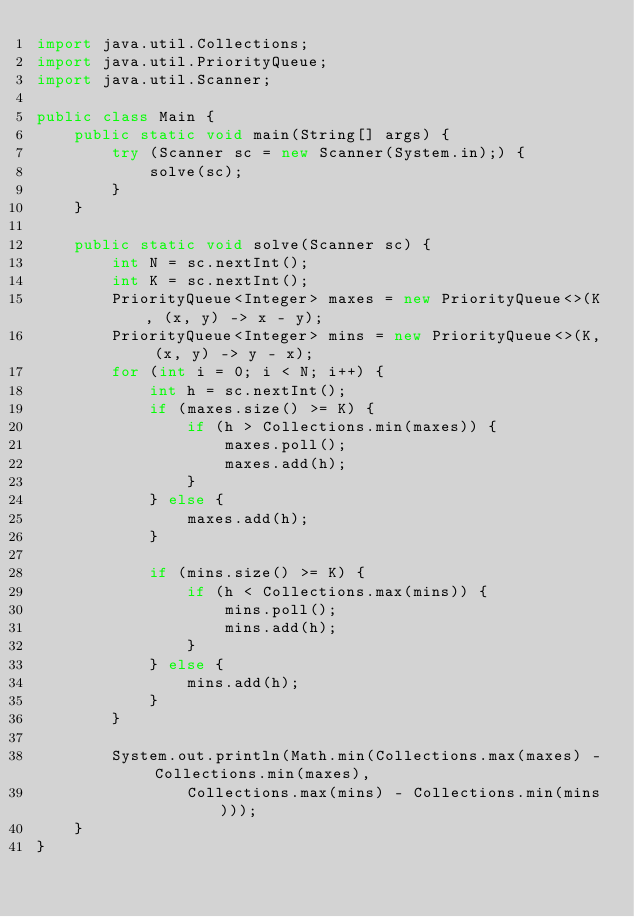<code> <loc_0><loc_0><loc_500><loc_500><_Java_>import java.util.Collections;
import java.util.PriorityQueue;
import java.util.Scanner;

public class Main {
    public static void main(String[] args) {
        try (Scanner sc = new Scanner(System.in);) {
            solve(sc);
        }
    }

    public static void solve(Scanner sc) {
        int N = sc.nextInt();
        int K = sc.nextInt();
        PriorityQueue<Integer> maxes = new PriorityQueue<>(K, (x, y) -> x - y);
        PriorityQueue<Integer> mins = new PriorityQueue<>(K, (x, y) -> y - x);
        for (int i = 0; i < N; i++) {
            int h = sc.nextInt();
            if (maxes.size() >= K) {
                if (h > Collections.min(maxes)) {
                    maxes.poll();
                    maxes.add(h);
                }
            } else {
                maxes.add(h);
            }

            if (mins.size() >= K) {
                if (h < Collections.max(mins)) {
                    mins.poll();
                    mins.add(h);
                }
            } else {
                mins.add(h);
            }
        }

        System.out.println(Math.min(Collections.max(maxes) - Collections.min(maxes),
                Collections.max(mins) - Collections.min(mins)));
    }
}</code> 